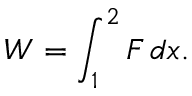<formula> <loc_0><loc_0><loc_500><loc_500>W = \int _ { 1 } ^ { 2 } F \, d x .</formula> 